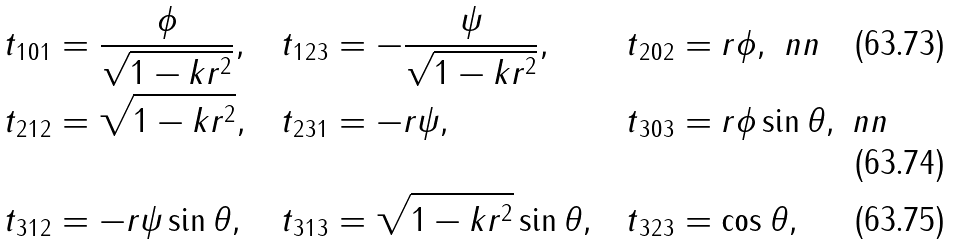Convert formula to latex. <formula><loc_0><loc_0><loc_500><loc_500>& t { _ { 1 } } { _ { 0 } } { _ { 1 } } = \frac { \phi } { \sqrt { 1 - k r ^ { 2 } } } , & & t { _ { 1 } } { _ { 2 } } { _ { 3 } } = - \frac { \psi } { \sqrt { 1 - k r ^ { 2 } } } , & & t { _ { 2 } } { _ { 0 } } { _ { 2 } } = r \phi , \ n n \\ & t { _ { 2 } } { _ { 1 } } { _ { 2 } } = \sqrt { 1 - k r ^ { 2 } } , & & t { _ { 2 } } { _ { 3 } } { _ { 1 } } = - r \psi , & & t { _ { 3 } } { _ { 0 } } { _ { 3 } } = r \phi \sin \theta , \ n n \\ & t { _ { 3 } } { _ { 1 } } { _ { 2 } } = - r \psi \sin \theta , & & t { _ { 3 } } { _ { 1 } } { _ { 3 } } = \sqrt { 1 - k r ^ { 2 } } \sin \theta , & & t { _ { 3 } } { _ { 2 } } { _ { 3 } } = \cos \theta ,</formula> 